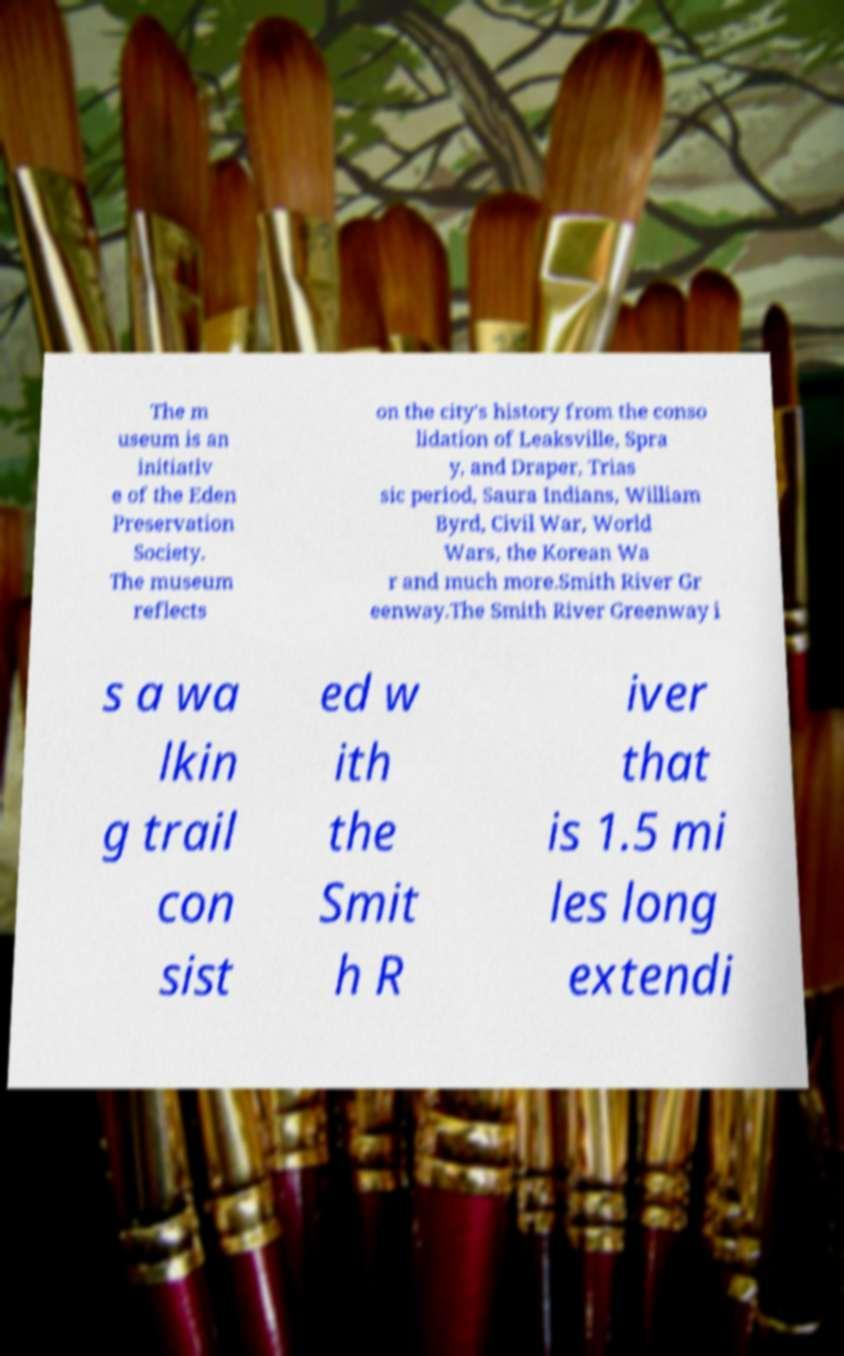There's text embedded in this image that I need extracted. Can you transcribe it verbatim? The m useum is an initiativ e of the Eden Preservation Society. The museum reflects on the city's history from the conso lidation of Leaksville, Spra y, and Draper, Trias sic period, Saura Indians, William Byrd, Civil War, World Wars, the Korean Wa r and much more.Smith River Gr eenway.The Smith River Greenway i s a wa lkin g trail con sist ed w ith the Smit h R iver that is 1.5 mi les long extendi 